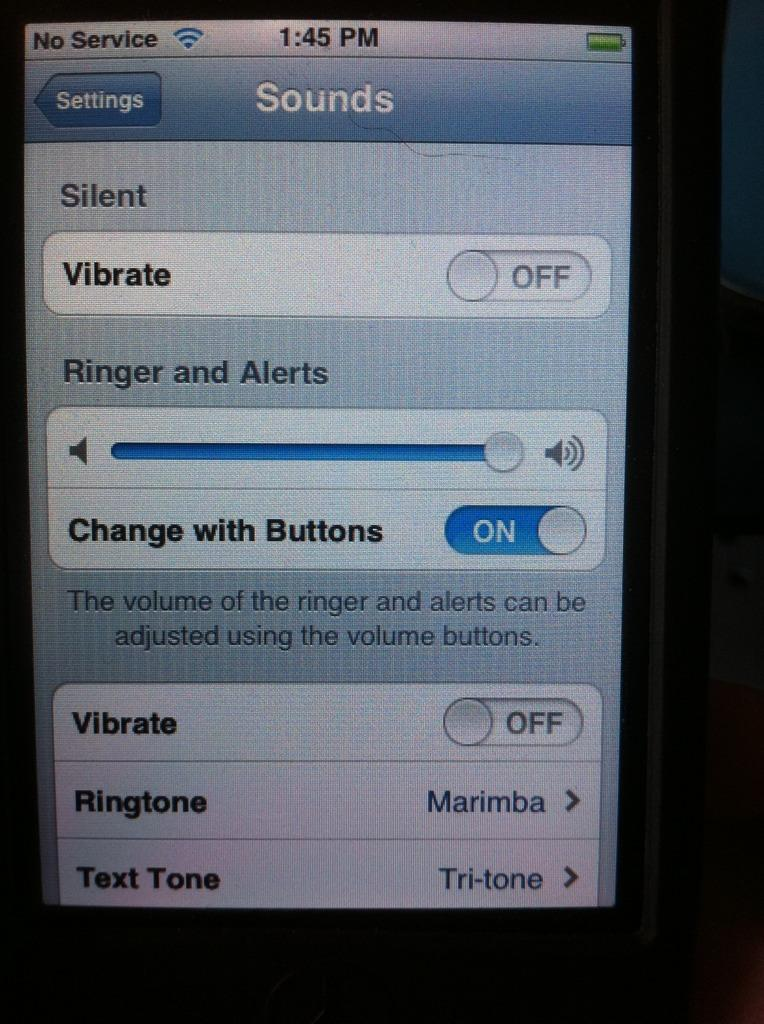<image>
Create a compact narrative representing the image presented. The screen of an old IOS version of an iPhone in the setting part in the sub menu sounds. 